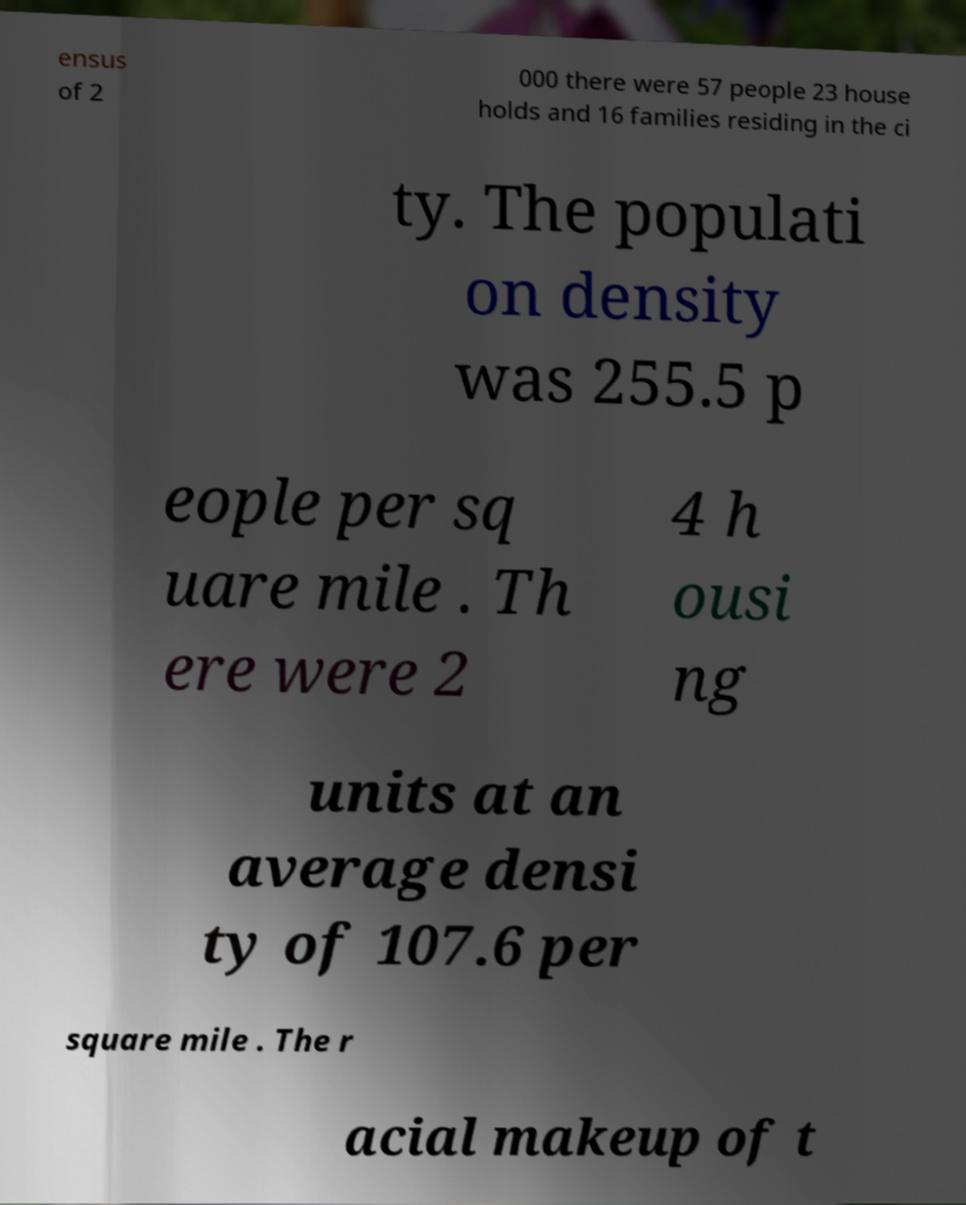Can you read and provide the text displayed in the image?This photo seems to have some interesting text. Can you extract and type it out for me? ensus of 2 000 there were 57 people 23 house holds and 16 families residing in the ci ty. The populati on density was 255.5 p eople per sq uare mile . Th ere were 2 4 h ousi ng units at an average densi ty of 107.6 per square mile . The r acial makeup of t 